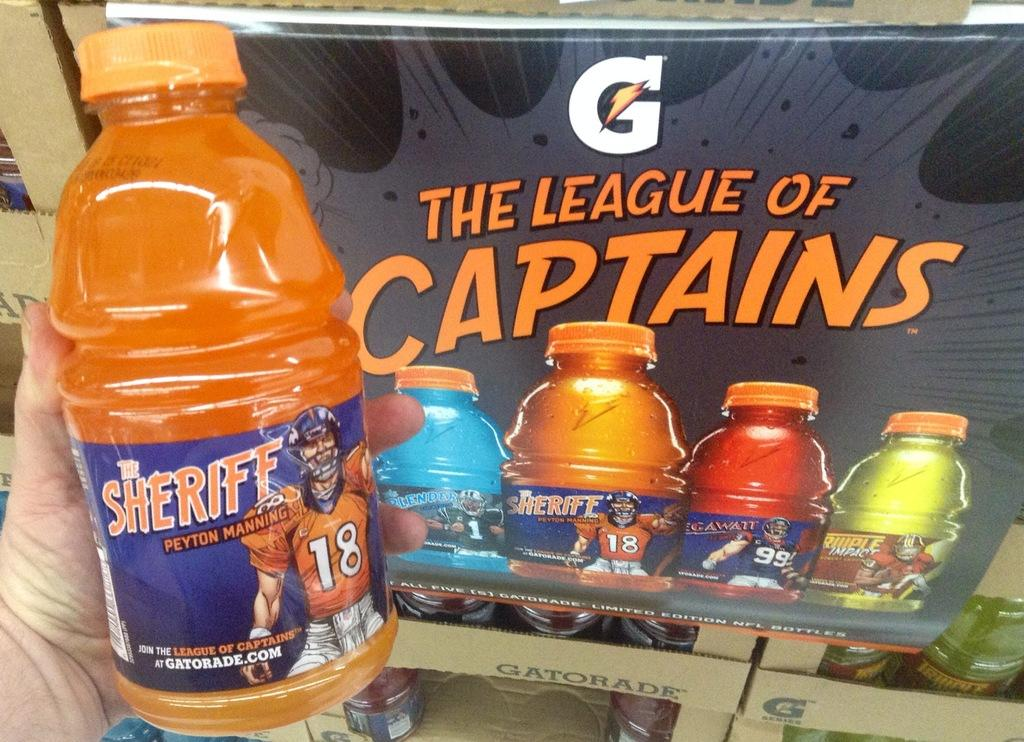<image>
Describe the image concisely. Banner with a G and The League of Captains in Orange. 